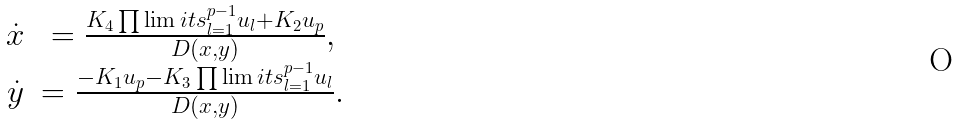Convert formula to latex. <formula><loc_0><loc_0><loc_500><loc_500>\begin{array} { c c } \dot { x } & = \frac { K _ { 4 } \prod \lim i t s _ { l = 1 } ^ { p - 1 } u _ { l } + K _ { 2 } u _ { p } } { D ( x , y ) } , \\ \dot { y } & = \frac { - K _ { 1 } u _ { p } - K _ { 3 } \prod \lim i t s _ { l = 1 } ^ { p - 1 } u _ { l } } { D ( x , y ) } . \end{array}</formula> 